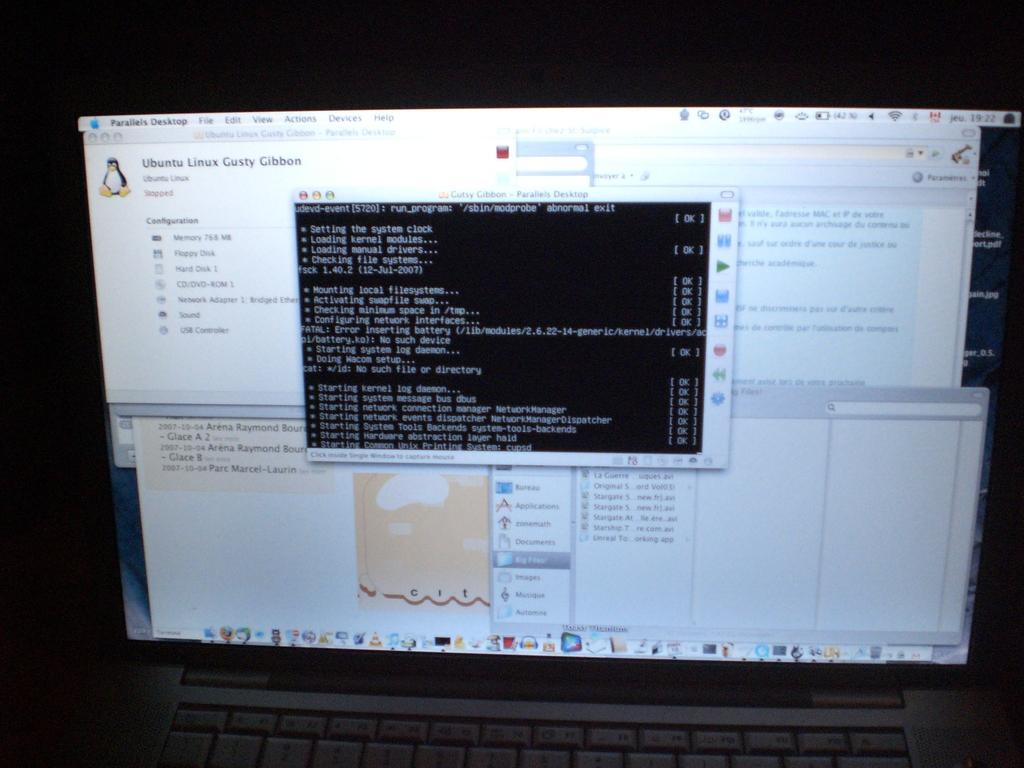<image>
Present a compact description of the photo's key features. An open MacBook screen with the program Parallels Desktop open. 